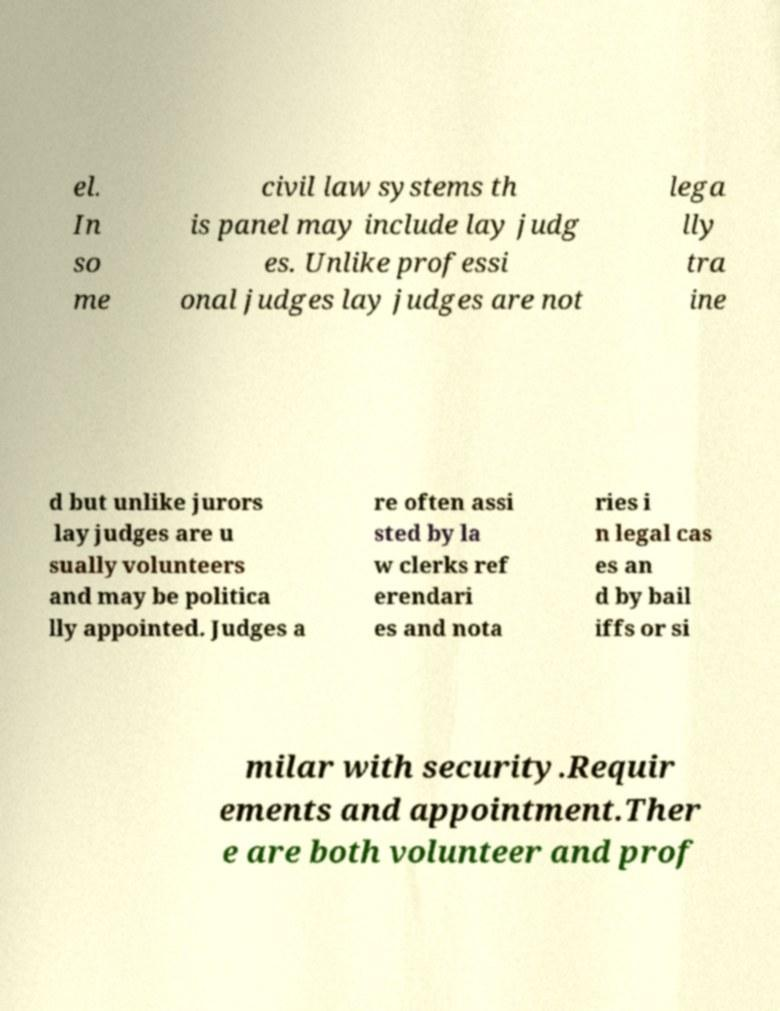Can you read and provide the text displayed in the image?This photo seems to have some interesting text. Can you extract and type it out for me? el. In so me civil law systems th is panel may include lay judg es. Unlike professi onal judges lay judges are not lega lly tra ine d but unlike jurors lay judges are u sually volunteers and may be politica lly appointed. Judges a re often assi sted by la w clerks ref erendari es and nota ries i n legal cas es an d by bail iffs or si milar with security.Requir ements and appointment.Ther e are both volunteer and prof 